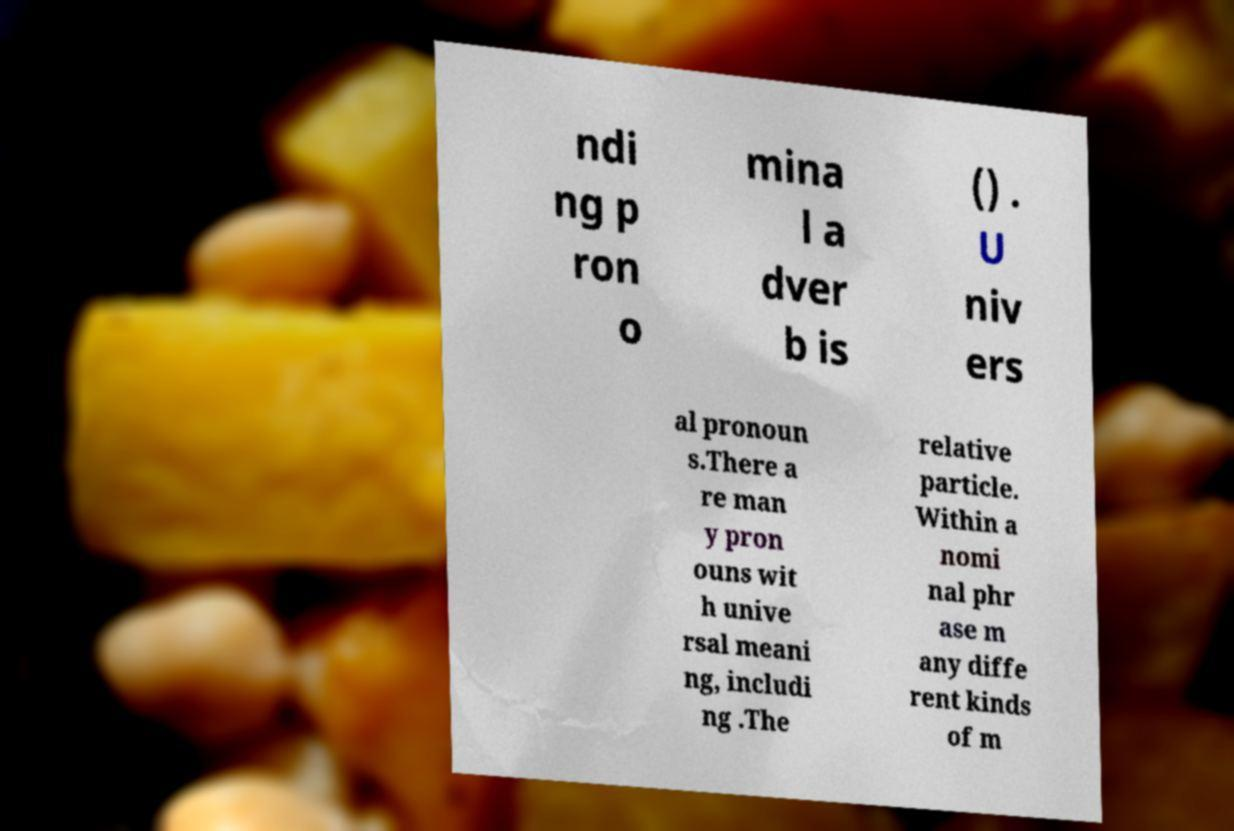Could you extract and type out the text from this image? ndi ng p ron o mina l a dver b is () . U niv ers al pronoun s.There a re man y pron ouns wit h unive rsal meani ng, includi ng .The relative particle. Within a nomi nal phr ase m any diffe rent kinds of m 